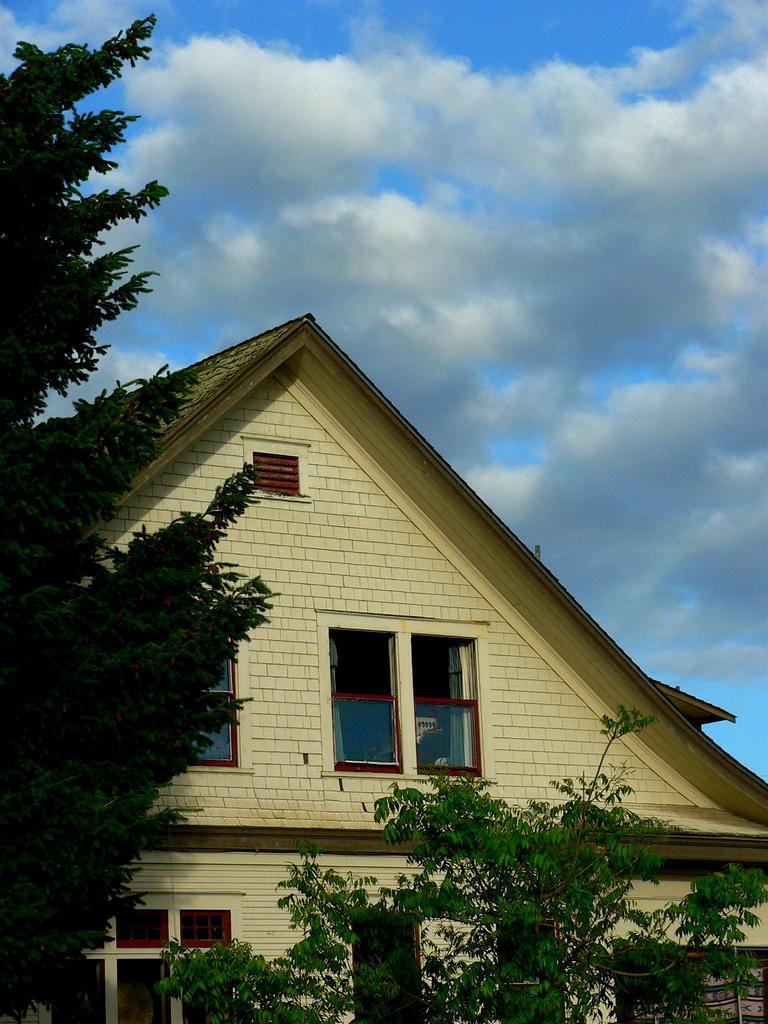Can you describe this image briefly? This picture is clicked outside. In the foreground we can see the plants. In the center there is a house and we can see the windows of the house. On the left we can see the trees. In the background there is a sky with the clouds. 